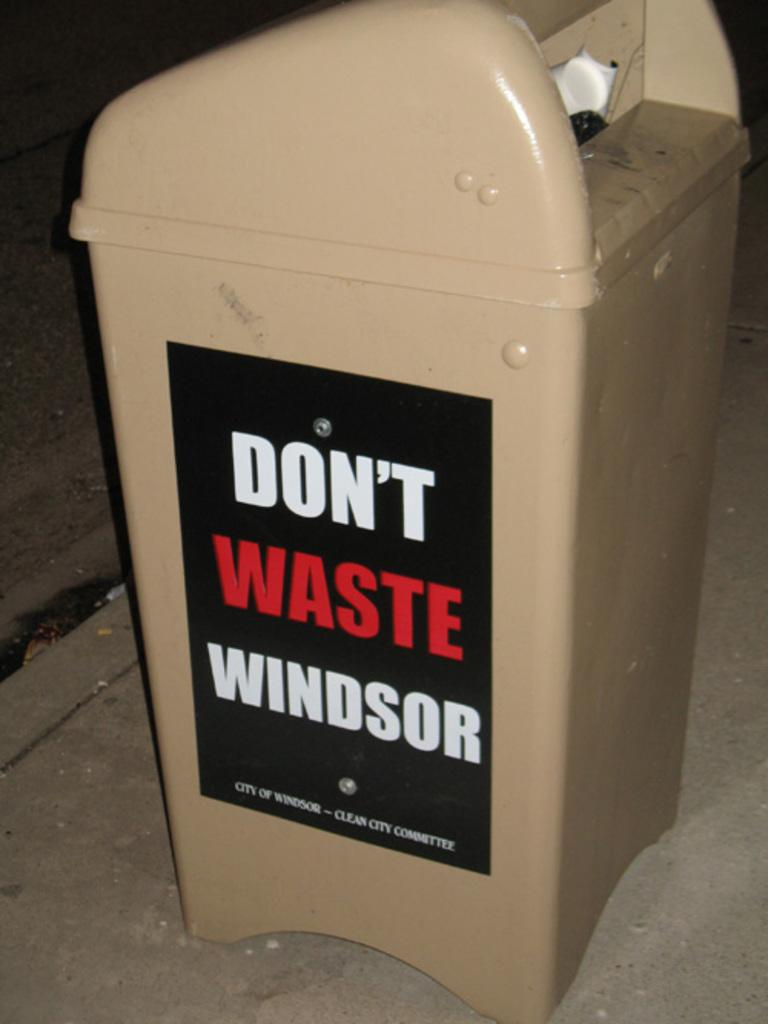Provide a one-sentence caption for the provided image. A trash can by the city of Windsor with an add on the side. 